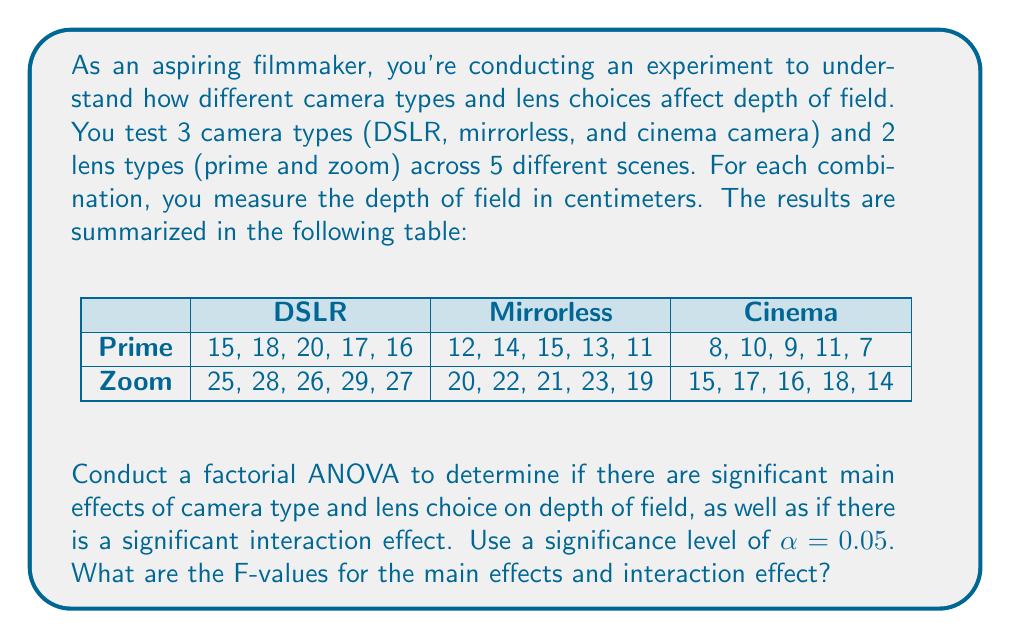Give your solution to this math problem. To conduct a factorial ANOVA, we need to follow these steps:

1. Calculate the total sum of squares (SST), sum of squares for camera type (SSA), sum of squares for lens type (SSB), sum of squares for interaction (SSAB), and sum of squares for error (SSE).

2. Calculate the degrees of freedom for each source of variation.

3. Calculate the mean squares for each source of variation.

4. Calculate the F-values for main effects and interaction effect.

Step 1: Calculate sums of squares

First, we need to calculate the grand mean:
$$\bar{X} = \frac{\text{Sum of all observations}}{\text{Total number of observations}} = \frac{525}{30} = 17.5$$

Now we can calculate SST:
$$SST = \sum_{i=1}^{3}\sum_{j=1}^{2}\sum_{k=1}^{5} (X_{ijk} - \bar{X})^2 = 1312.5$$

For SSA (camera type):
$$SSA = 5 \cdot 2 \cdot \sum_{i=1}^{3} (\bar{X_i} - \bar{X})^2 = 787.5$$

For SSB (lens type):
$$SSB = 5 \cdot 3 \cdot \sum_{j=1}^{2} (\bar{X_j} - \bar{X})^2 = 375$$

For SSAB (interaction):
$$SSAB = 5 \cdot \sum_{i=1}^{3}\sum_{j=1}^{2} (\bar{X_{ij}} - \bar{X_i} - \bar{X_j} + \bar{X})^2 = 37.5$$

SSE can be calculated as:
$$SSE = SST - SSA - SSB - SSAB = 112.5$$

Step 2: Degrees of freedom

- dfA = 3 - 1 = 2 (camera type)
- dfB = 2 - 1 = 1 (lens type)
- dfAB = 2 * 1 = 2 (interaction)
- dfE = 30 - (3*2) = 24 (error)

Step 3: Mean squares

$$MSA = \frac{SSA}{dfA} = \frac{787.5}{2} = 393.75$$
$$MSB = \frac{SSB}{dfB} = \frac{375}{1} = 375$$
$$MSAB = \frac{SSAB}{dfAB} = \frac{37.5}{2} = 18.75$$
$$MSE = \frac{SSE}{dfE} = \frac{112.5}{24} = 4.6875$$

Step 4: F-values

$$F_A = \frac{MSA}{MSE} = \frac{393.75}{4.6875} = 84$$
$$F_B = \frac{MSB}{MSE} = \frac{375}{4.6875} = 80$$
$$F_{AB} = \frac{MSAB}{MSE} = \frac{18.75}{4.6875} = 4$$
Answer: $F_A = 84$, $F_B = 80$, $F_{AB} = 4$ 